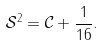<formula> <loc_0><loc_0><loc_500><loc_500>\mathcal { S } ^ { 2 } = \mathcal { C } + \frac { 1 } { 1 6 } .</formula> 